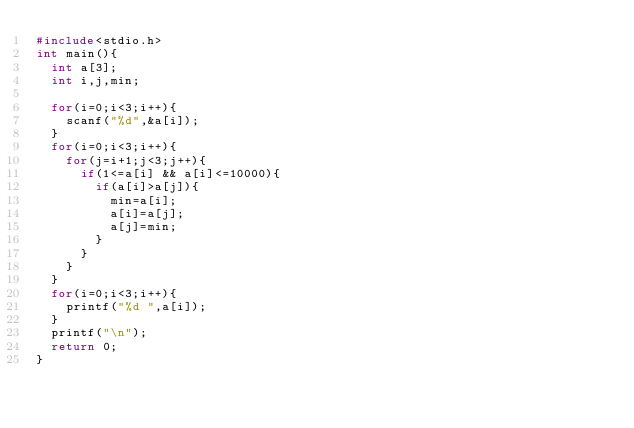<code> <loc_0><loc_0><loc_500><loc_500><_C_>#include<stdio.h>
int main(){
  int a[3];
  int i,j,min;

  for(i=0;i<3;i++){
    scanf("%d",&a[i]);
  }
  for(i=0;i<3;i++){
    for(j=i+1;j<3;j++){
      if(1<=a[i] && a[i]<=10000){
        if(a[i]>a[j]){
          min=a[i];
          a[i]=a[j];
          a[j]=min;
        }
      }
    }
  }
  for(i=0;i<3;i++){
    printf("%d ",a[i]);
  }
  printf("\n");
  return 0;
}</code> 